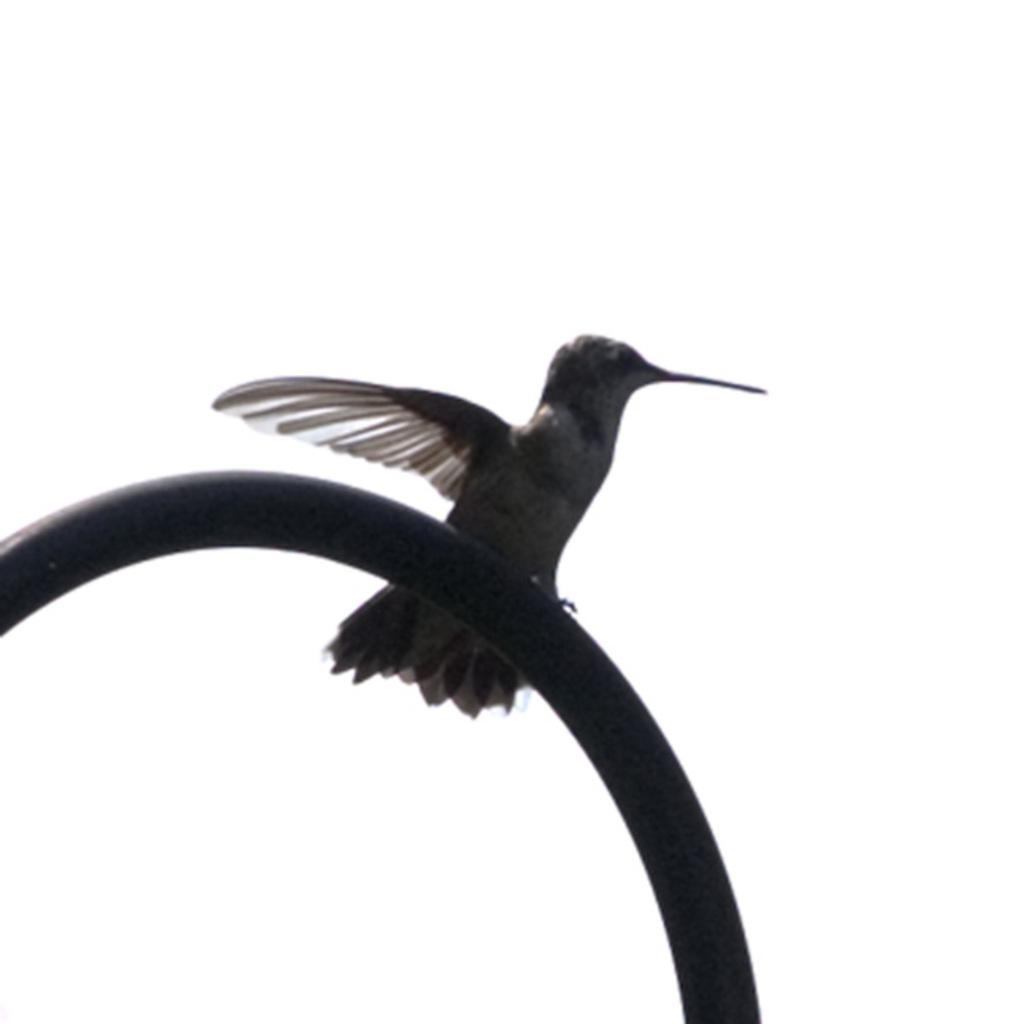What type of animal can be seen in the image? There is a bird in the image. Where is the bird located? The bird is on a pipeline. What type of wool is the bird using to knit a scarf in the image? There is no wool or scarf present in the image; it features a bird on a pipeline. Can you see a playground in the background of the image? There is no playground visible in the image; it only shows a bird on a pipeline. 